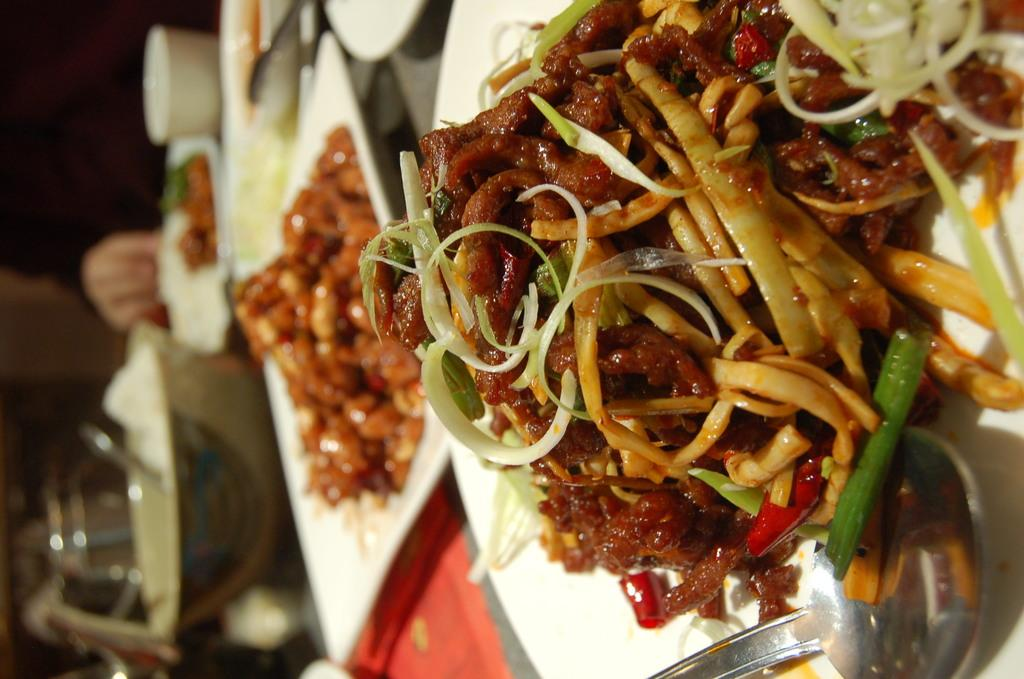What is on the plate in the image? There is food on a plate in the image. What utensil is visible in the image? There is a spoon visible in the image. What can be seen on the surface in the image? There are objects on the surface in the image. What type of cart is parked in the bedroom in the image? There is no cart or bedroom present in the image. 